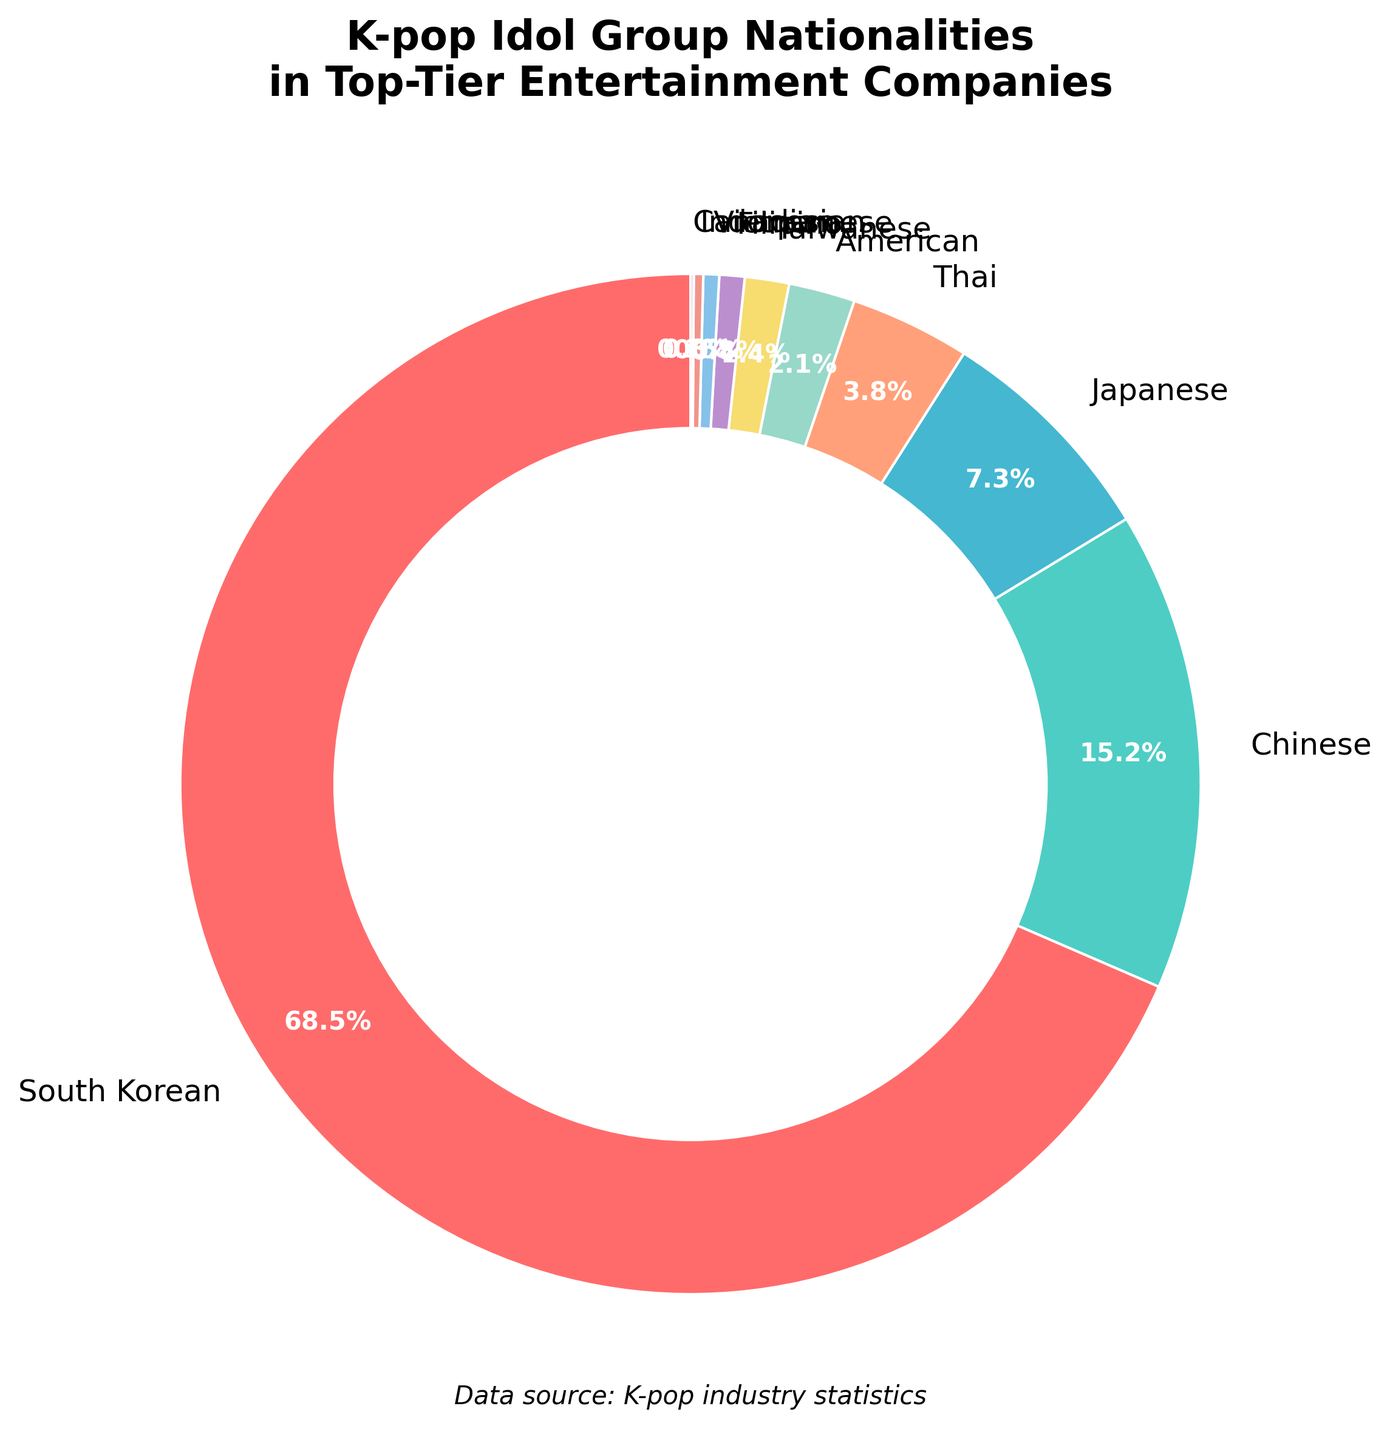What percentage of K-pop idol group members come from South Korea and China combined? To find the combined percentage of members from South Korea and China, add their individual percentages: 68.5% (South Korean) + 15.2% (Chinese) = 83.7%.
Answer: 83.7% Which nationality has the lowest representation in the K-pop idol groups according to the chart? The nationality with the lowest percentage is the one with the smallest slice in the pie chart. That would be Canadian with 0.1%.
Answer: Canadian How much more represented are Japanese nationals compared to American nationals in K-pop idol groups? The percentage of Japanese nationals is 7.3%, and the percentage of American nationals is 2.1%. Subtracting the latter from the former, 7.3% - 2.1% = 5.2%.
Answer: 5.2% Which three nationalities make up the majority of the pie chart? The majority is over 50%. By looking at the slices, South Korean (68.5%), Chinese (15.2%), and Japanese (7.3%) together add up to 68.5% + 15.2% + 7.3% = 91%. These three nationalities are the majority.
Answer: South Korean, Chinese, Japanese What's the difference in percentage points between Thai and Taiwanese members? The Thai percentage is 3.8%, and the Taiwanese percentage is 1.4%. The difference is calculated by 3.8% - 1.4% = 2.4%.
Answer: 2.4% How many nationalities have a representation of 5% or less? The nationalities with 5% or less are: American (2.1%), Taiwanese (1.4%), Filipino (0.8%), Vietnamese (0.5%), Indonesian (0.3%), and Canadian (0.1%). Counting these, there are 6 nationalities.
Answer: 6 What is the combined percentage of non-South Korean K-pop idols? The total percentage for all nationalities is 100%. Subtract the South Korean percentage to find the non-Korean percentage: 100% - 68.5% = 31.5%.
Answer: 31.5% Which nationality uses the blue-colored slice in the pie chart? Observing the pie chart shows the slice corresponding to "Japanese" is blue.
Answer: Japanese If South Korean representation decreased by 10%, what would their new percentage be? The current South Korean percentage is 68.5%. A 10% decrease is 68.5% * 10/100 = 6.85%. Subtracting this from the original, 68.5% - 6.85% = 61.65%.
Answer: 61.65% How does the Thai representation compare to the Filipino representation? The Thai representation is 3.8%, whereas the Filipino representation is 0.8%. Thai is greater by 3.8% - 0.8% = 3%.
Answer: 3% more 